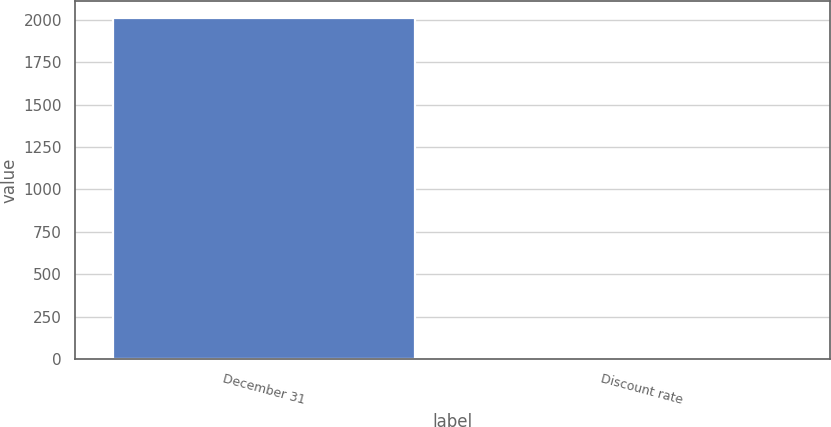Convert chart. <chart><loc_0><loc_0><loc_500><loc_500><bar_chart><fcel>December 31<fcel>Discount rate<nl><fcel>2007<fcel>5.33<nl></chart> 